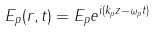<formula> <loc_0><loc_0><loc_500><loc_500>E _ { p } ( r , t ) = E _ { p } e ^ { i ( k _ { p } z - \omega _ { p } t ) }</formula> 